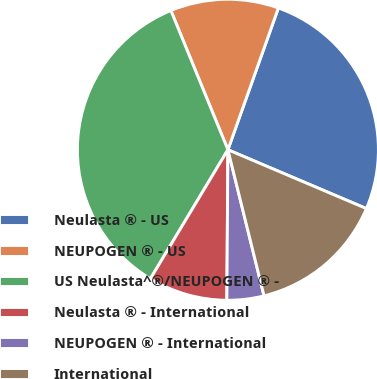Convert chart. <chart><loc_0><loc_0><loc_500><loc_500><pie_chart><fcel>Neulasta ® - US<fcel>NEUPOGEN ® - US<fcel>US Neulasta^®/NEUPOGEN ® -<fcel>Neulasta ® - International<fcel>NEUPOGEN ® - International<fcel>International<nl><fcel>25.95%<fcel>11.63%<fcel>35.2%<fcel>8.5%<fcel>3.97%<fcel>14.75%<nl></chart> 